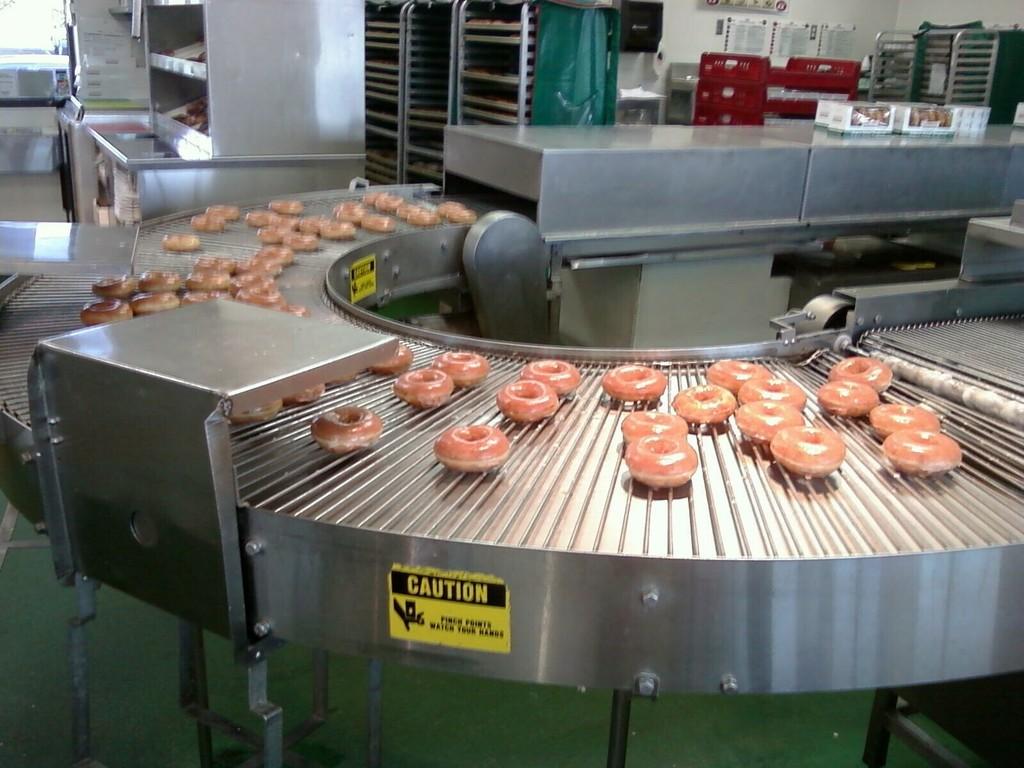What is the caution sign?
Provide a succinct answer. Pinch points watch your hands. 